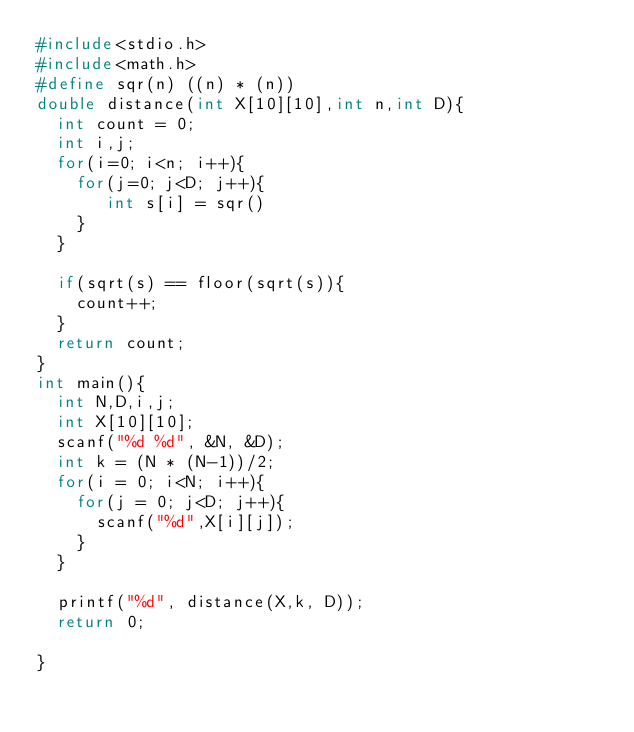Convert code to text. <code><loc_0><loc_0><loc_500><loc_500><_C_>#include<stdio.h>
#include<math.h>
#define sqr(n) ((n) * (n))
double distance(int X[10][10],int n,int D){
  int count = 0;
  int i,j;
  for(i=0; i<n; i++){
    for(j=0; j<D; j++){
       int s[i] = sqr()
    }
  }
  
  if(sqrt(s) == floor(sqrt(s)){
    count++;
  }
  return count;
}
int main(){
  int N,D,i,j;
  int X[10][10];
  scanf("%d %d", &N, &D);
  int k = (N * (N-1))/2;
  for(i = 0; i<N; i++){
    for(j = 0; j<D; j++){
      scanf("%d",X[i][j]);
    }
  }
  
  printf("%d", distance(X,k, D));
  return 0;

}</code> 